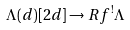Convert formula to latex. <formula><loc_0><loc_0><loc_500><loc_500>\Lambda ( d ) [ 2 d ] \to R f ^ { ! } \Lambda</formula> 